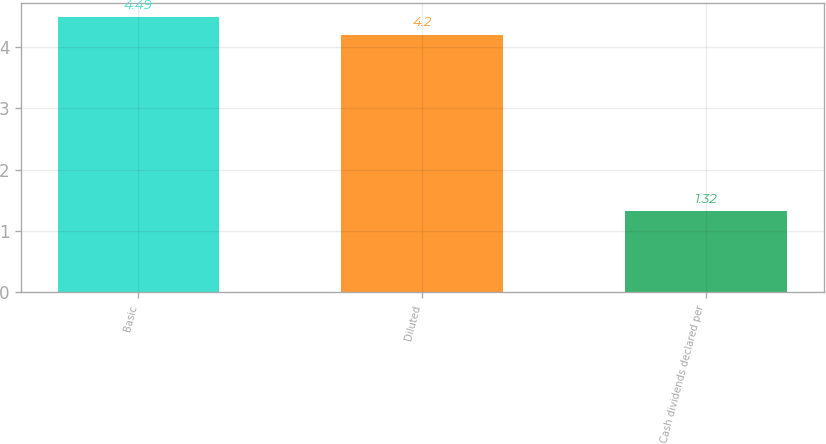<chart> <loc_0><loc_0><loc_500><loc_500><bar_chart><fcel>Basic<fcel>Diluted<fcel>Cash dividends declared per<nl><fcel>4.49<fcel>4.2<fcel>1.32<nl></chart> 